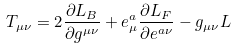Convert formula to latex. <formula><loc_0><loc_0><loc_500><loc_500>T _ { \mu \nu } = 2 \frac { \partial L _ { B } } { \partial g ^ { \mu \nu } } + e ^ { a } _ { \mu } \frac { \partial L _ { F } } { \partial e ^ { a \nu } } - g _ { \mu \nu } L</formula> 